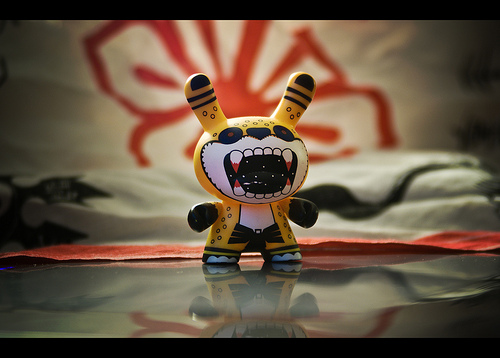<image>
Can you confirm if the paper is in front of the figure? No. The paper is not in front of the figure. The spatial positioning shows a different relationship between these objects. 